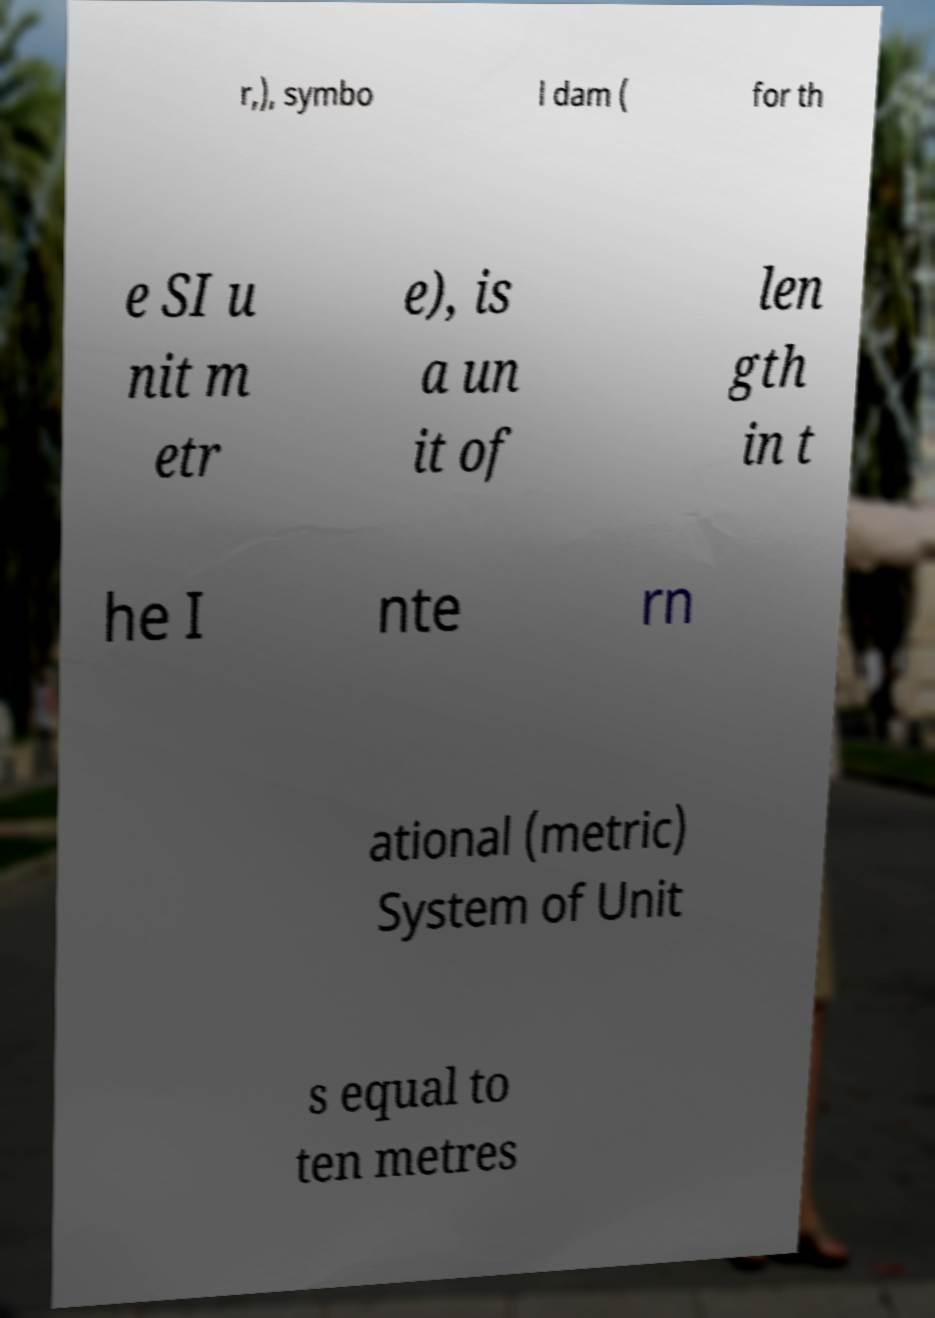Could you assist in decoding the text presented in this image and type it out clearly? r,), symbo l dam ( for th e SI u nit m etr e), is a un it of len gth in t he I nte rn ational (metric) System of Unit s equal to ten metres 